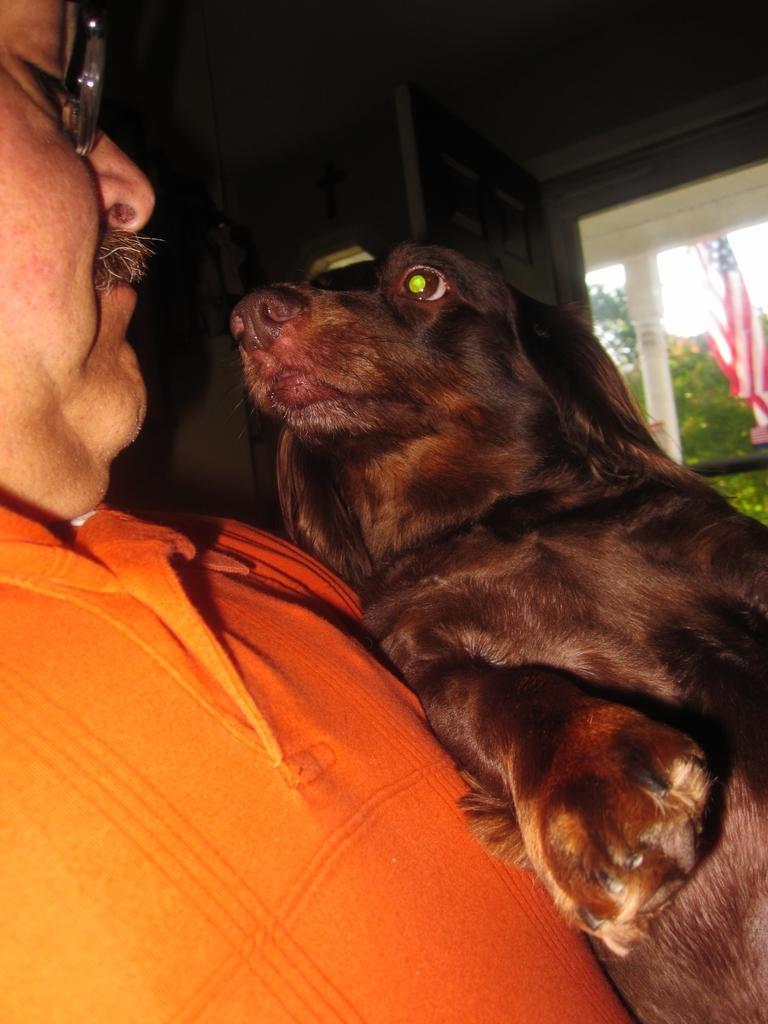Describe this image in one or two sentences. This is the picture of a man in orange t shirt holding a dog. Background of the man is a wall, a tree and a flag. 